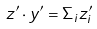<formula> <loc_0><loc_0><loc_500><loc_500>z ^ { \prime } \cdot y ^ { \prime } = \Sigma _ { i } z _ { i } ^ { \prime }</formula> 